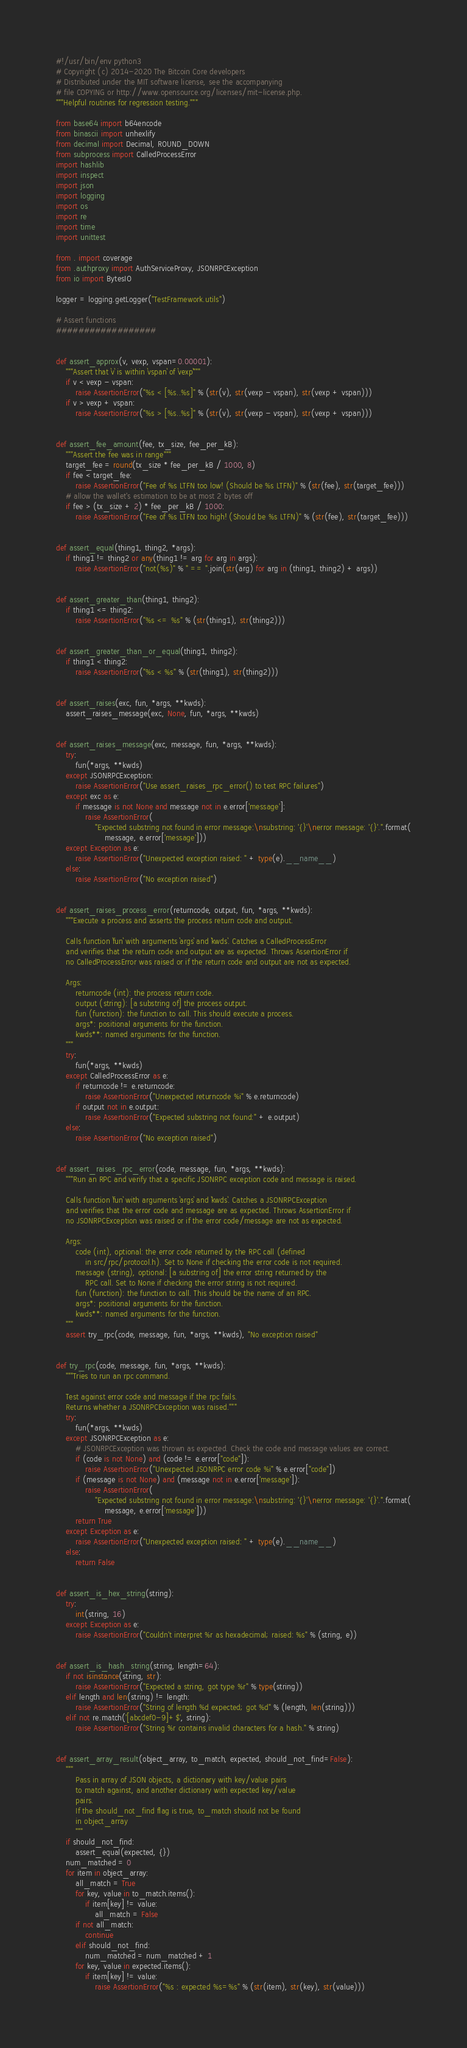Convert code to text. <code><loc_0><loc_0><loc_500><loc_500><_Python_>#!/usr/bin/env python3
# Copyright (c) 2014-2020 The Bitcoin Core developers
# Distributed under the MIT software license, see the accompanying
# file COPYING or http://www.opensource.org/licenses/mit-license.php.
"""Helpful routines for regression testing."""

from base64 import b64encode
from binascii import unhexlify
from decimal import Decimal, ROUND_DOWN
from subprocess import CalledProcessError
import hashlib
import inspect
import json
import logging
import os
import re
import time
import unittest

from . import coverage
from .authproxy import AuthServiceProxy, JSONRPCException
from io import BytesIO

logger = logging.getLogger("TestFramework.utils")

# Assert functions
##################


def assert_approx(v, vexp, vspan=0.00001):
    """Assert that `v` is within `vspan` of `vexp`"""
    if v < vexp - vspan:
        raise AssertionError("%s < [%s..%s]" % (str(v), str(vexp - vspan), str(vexp + vspan)))
    if v > vexp + vspan:
        raise AssertionError("%s > [%s..%s]" % (str(v), str(vexp - vspan), str(vexp + vspan)))


def assert_fee_amount(fee, tx_size, fee_per_kB):
    """Assert the fee was in range"""
    target_fee = round(tx_size * fee_per_kB / 1000, 8)
    if fee < target_fee:
        raise AssertionError("Fee of %s LTFN too low! (Should be %s LTFN)" % (str(fee), str(target_fee)))
    # allow the wallet's estimation to be at most 2 bytes off
    if fee > (tx_size + 2) * fee_per_kB / 1000:
        raise AssertionError("Fee of %s LTFN too high! (Should be %s LTFN)" % (str(fee), str(target_fee)))


def assert_equal(thing1, thing2, *args):
    if thing1 != thing2 or any(thing1 != arg for arg in args):
        raise AssertionError("not(%s)" % " == ".join(str(arg) for arg in (thing1, thing2) + args))


def assert_greater_than(thing1, thing2):
    if thing1 <= thing2:
        raise AssertionError("%s <= %s" % (str(thing1), str(thing2)))


def assert_greater_than_or_equal(thing1, thing2):
    if thing1 < thing2:
        raise AssertionError("%s < %s" % (str(thing1), str(thing2)))


def assert_raises(exc, fun, *args, **kwds):
    assert_raises_message(exc, None, fun, *args, **kwds)


def assert_raises_message(exc, message, fun, *args, **kwds):
    try:
        fun(*args, **kwds)
    except JSONRPCException:
        raise AssertionError("Use assert_raises_rpc_error() to test RPC failures")
    except exc as e:
        if message is not None and message not in e.error['message']:
            raise AssertionError(
                "Expected substring not found in error message:\nsubstring: '{}'\nerror message: '{}'.".format(
                    message, e.error['message']))
    except Exception as e:
        raise AssertionError("Unexpected exception raised: " + type(e).__name__)
    else:
        raise AssertionError("No exception raised")


def assert_raises_process_error(returncode, output, fun, *args, **kwds):
    """Execute a process and asserts the process return code and output.

    Calls function `fun` with arguments `args` and `kwds`. Catches a CalledProcessError
    and verifies that the return code and output are as expected. Throws AssertionError if
    no CalledProcessError was raised or if the return code and output are not as expected.

    Args:
        returncode (int): the process return code.
        output (string): [a substring of] the process output.
        fun (function): the function to call. This should execute a process.
        args*: positional arguments for the function.
        kwds**: named arguments for the function.
    """
    try:
        fun(*args, **kwds)
    except CalledProcessError as e:
        if returncode != e.returncode:
            raise AssertionError("Unexpected returncode %i" % e.returncode)
        if output not in e.output:
            raise AssertionError("Expected substring not found:" + e.output)
    else:
        raise AssertionError("No exception raised")


def assert_raises_rpc_error(code, message, fun, *args, **kwds):
    """Run an RPC and verify that a specific JSONRPC exception code and message is raised.

    Calls function `fun` with arguments `args` and `kwds`. Catches a JSONRPCException
    and verifies that the error code and message are as expected. Throws AssertionError if
    no JSONRPCException was raised or if the error code/message are not as expected.

    Args:
        code (int), optional: the error code returned by the RPC call (defined
            in src/rpc/protocol.h). Set to None if checking the error code is not required.
        message (string), optional: [a substring of] the error string returned by the
            RPC call. Set to None if checking the error string is not required.
        fun (function): the function to call. This should be the name of an RPC.
        args*: positional arguments for the function.
        kwds**: named arguments for the function.
    """
    assert try_rpc(code, message, fun, *args, **kwds), "No exception raised"


def try_rpc(code, message, fun, *args, **kwds):
    """Tries to run an rpc command.

    Test against error code and message if the rpc fails.
    Returns whether a JSONRPCException was raised."""
    try:
        fun(*args, **kwds)
    except JSONRPCException as e:
        # JSONRPCException was thrown as expected. Check the code and message values are correct.
        if (code is not None) and (code != e.error["code"]):
            raise AssertionError("Unexpected JSONRPC error code %i" % e.error["code"])
        if (message is not None) and (message not in e.error['message']):
            raise AssertionError(
                "Expected substring not found in error message:\nsubstring: '{}'\nerror message: '{}'.".format(
                    message, e.error['message']))
        return True
    except Exception as e:
        raise AssertionError("Unexpected exception raised: " + type(e).__name__)
    else:
        return False


def assert_is_hex_string(string):
    try:
        int(string, 16)
    except Exception as e:
        raise AssertionError("Couldn't interpret %r as hexadecimal; raised: %s" % (string, e))


def assert_is_hash_string(string, length=64):
    if not isinstance(string, str):
        raise AssertionError("Expected a string, got type %r" % type(string))
    elif length and len(string) != length:
        raise AssertionError("String of length %d expected; got %d" % (length, len(string)))
    elif not re.match('[abcdef0-9]+$', string):
        raise AssertionError("String %r contains invalid characters for a hash." % string)


def assert_array_result(object_array, to_match, expected, should_not_find=False):
    """
        Pass in array of JSON objects, a dictionary with key/value pairs
        to match against, and another dictionary with expected key/value
        pairs.
        If the should_not_find flag is true, to_match should not be found
        in object_array
        """
    if should_not_find:
        assert_equal(expected, {})
    num_matched = 0
    for item in object_array:
        all_match = True
        for key, value in to_match.items():
            if item[key] != value:
                all_match = False
        if not all_match:
            continue
        elif should_not_find:
            num_matched = num_matched + 1
        for key, value in expected.items():
            if item[key] != value:
                raise AssertionError("%s : expected %s=%s" % (str(item), str(key), str(value)))</code> 